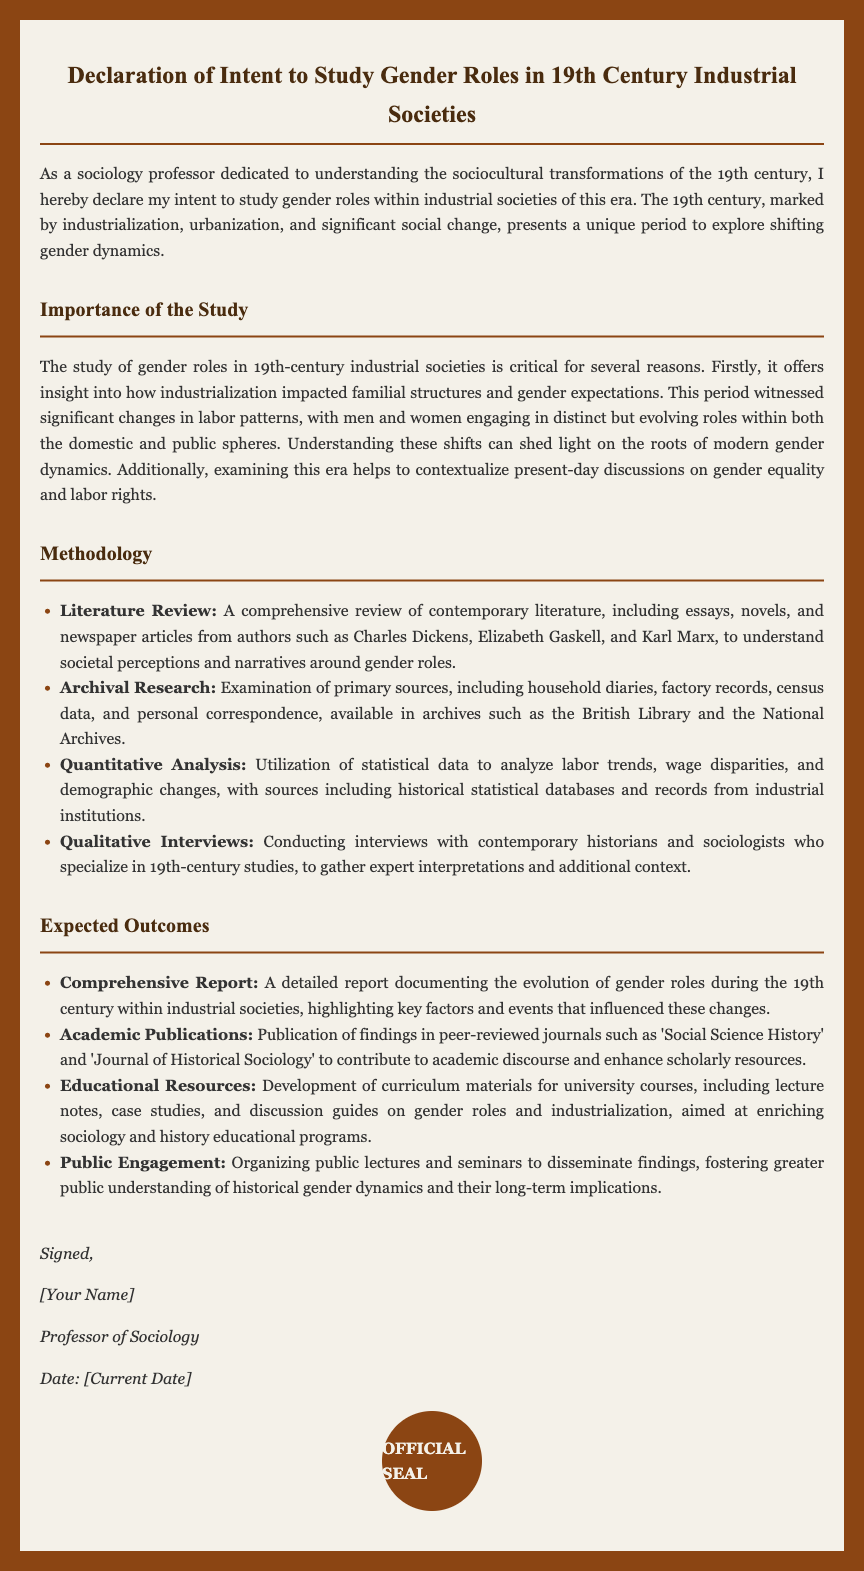What is the title of the document? The title of the document is clearly stated at the top of the rendered HTML.
Answer: Declaration of Intent to Study Gender Roles in 19th Century Industrial Societies What century is the focus of the study? The document explicitly mentions the century being studied in the introduction.
Answer: 19th century Which authors are included in the literature review? The document lists specific authors considered in the literature review under the methodology section.
Answer: Charles Dickens, Elizabeth Gaskell, and Karl Marx What type of research involves examining primary sources? The methodology section outlines a specific type of research dedicated to primary source investigation.
Answer: Archival Research What is one expected outcome of the study? The document lists several expected outcomes at the end of the methodology, which include various scholarly contributions.
Answer: Comprehensive Report What will be developed for university courses based on the study findings? The document specifies materials that will be created for educational purposes within the expected outcomes.
Answer: Educational Resources How many research methodologies are listed in the document? The document enumerates the different methodologies used for the study in a structured list.
Answer: Four Who is the document signed by? The signature section of the document includes details about the signatory.
Answer: [Your Name] 